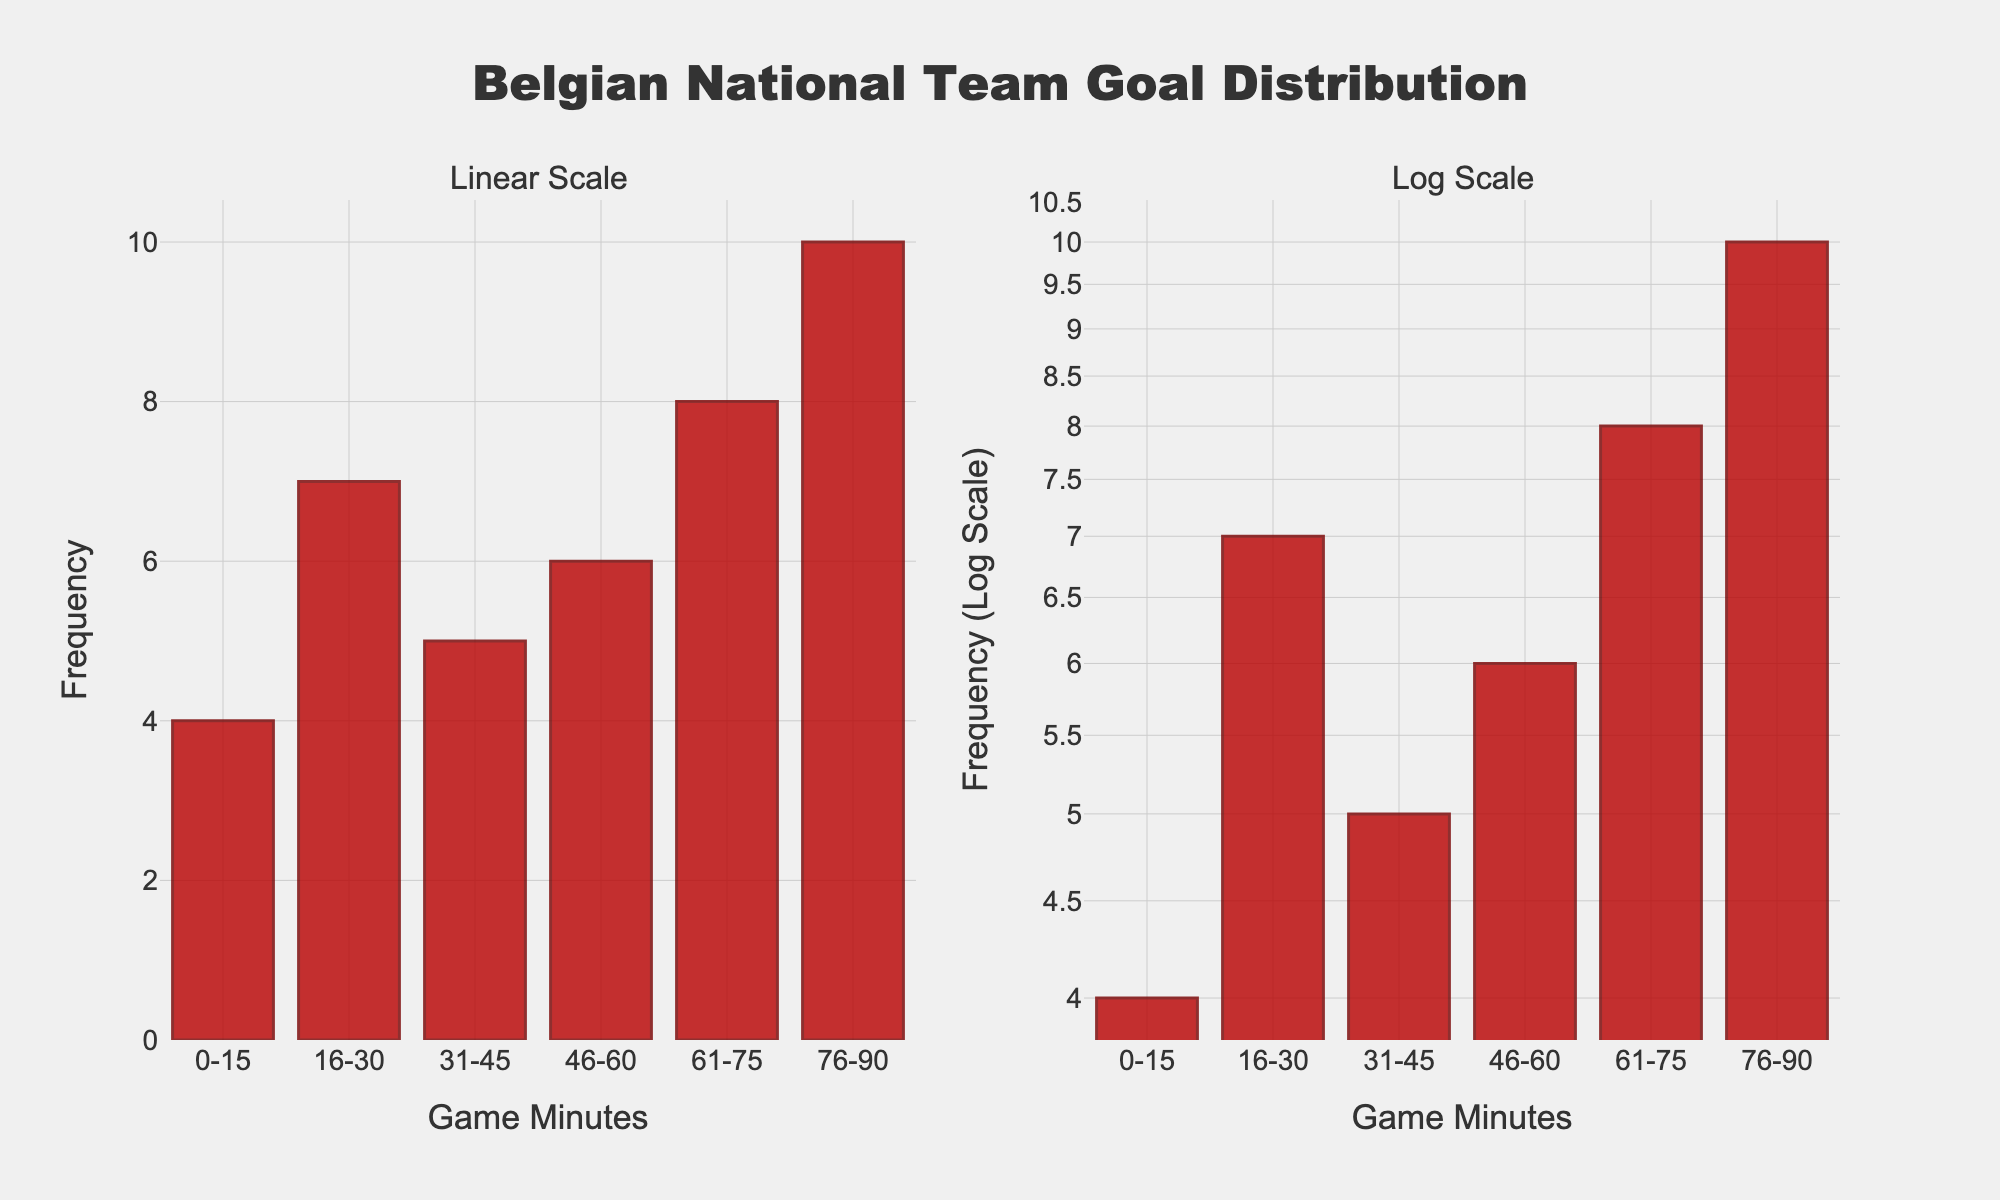What is the title of the figure? The title is displayed at the top center of the figure. It reads "Belgian National Team Goal Distribution".
Answer: Belgian National Team Goal Distribution How many minutes intervals are shown in the figure? The x-axis labels show different intervals of game minutes. There are six intervals: "0-15", "16-30", "31-45", "46-60", "61-75", and "76-90".
Answer: 6 Which minute interval has the highest frequency of goals? By observing both subplots, the highest frequency bar is for the "76-90" minute interval.
Answer: 76-90 What is the frequency of goals scored between the 31st and 45th minute? The bar for the "31-45" interval represents the frequency of goals which is 5.
Answer: 5 How do the frequencies of goals scored between the 16-30 minutes and 46-60 minutes compare? Comparing the two bars, the "16-30" minute interval has a higher frequency (7) than the "46-60" minute interval (6).
Answer: 16-30 > 46-60 What is the sum of the frequencies for the first half of the game (0-45 minutes)? Adding the frequencies: 0-15 (4), 16-30 (7), and 31-45 (5), we get 4 + 7 + 5 = 16.
Answer: 16 What's the average frequency of goals scored across all intervals? The total frequency is 4 + 7 + 5 + 6 + 8 + 10 = 40. There are 6 intervals, so the average frequency is 40 / 6 ≈ 6.67.
Answer: 6.67 Which interval showed the least change in frequency when converted to a log scale? The bar heights for lower frequencies (4, 5, 6) appear more compressed in the log scale subplot, with the "0-15" interval showing the least change visually.
Answer: 0-15 What is the frequency for the interval "61-75" in the log scale plot? Reading the height of the bar for "61-75" interval in the log scale plot, it still represents a frequency of 8. The log scale does not change the actual frequency values, only their visual representation.
Answer: 8 